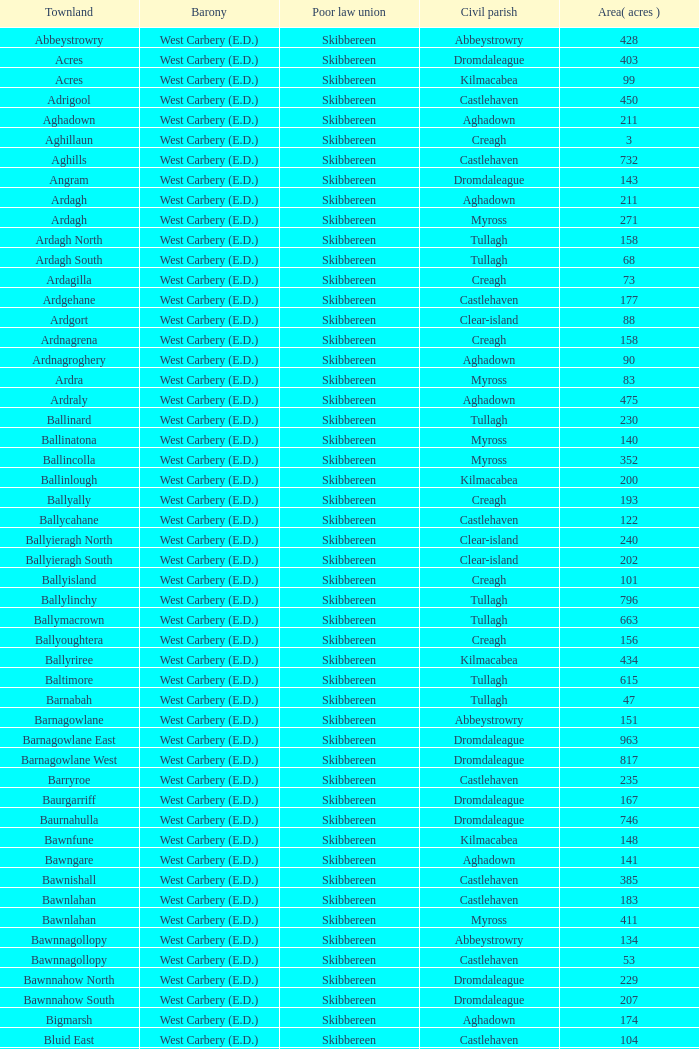What is the greatest area when the Poor Law Union is Skibbereen and the Civil Parish is Tullagh? 796.0. 